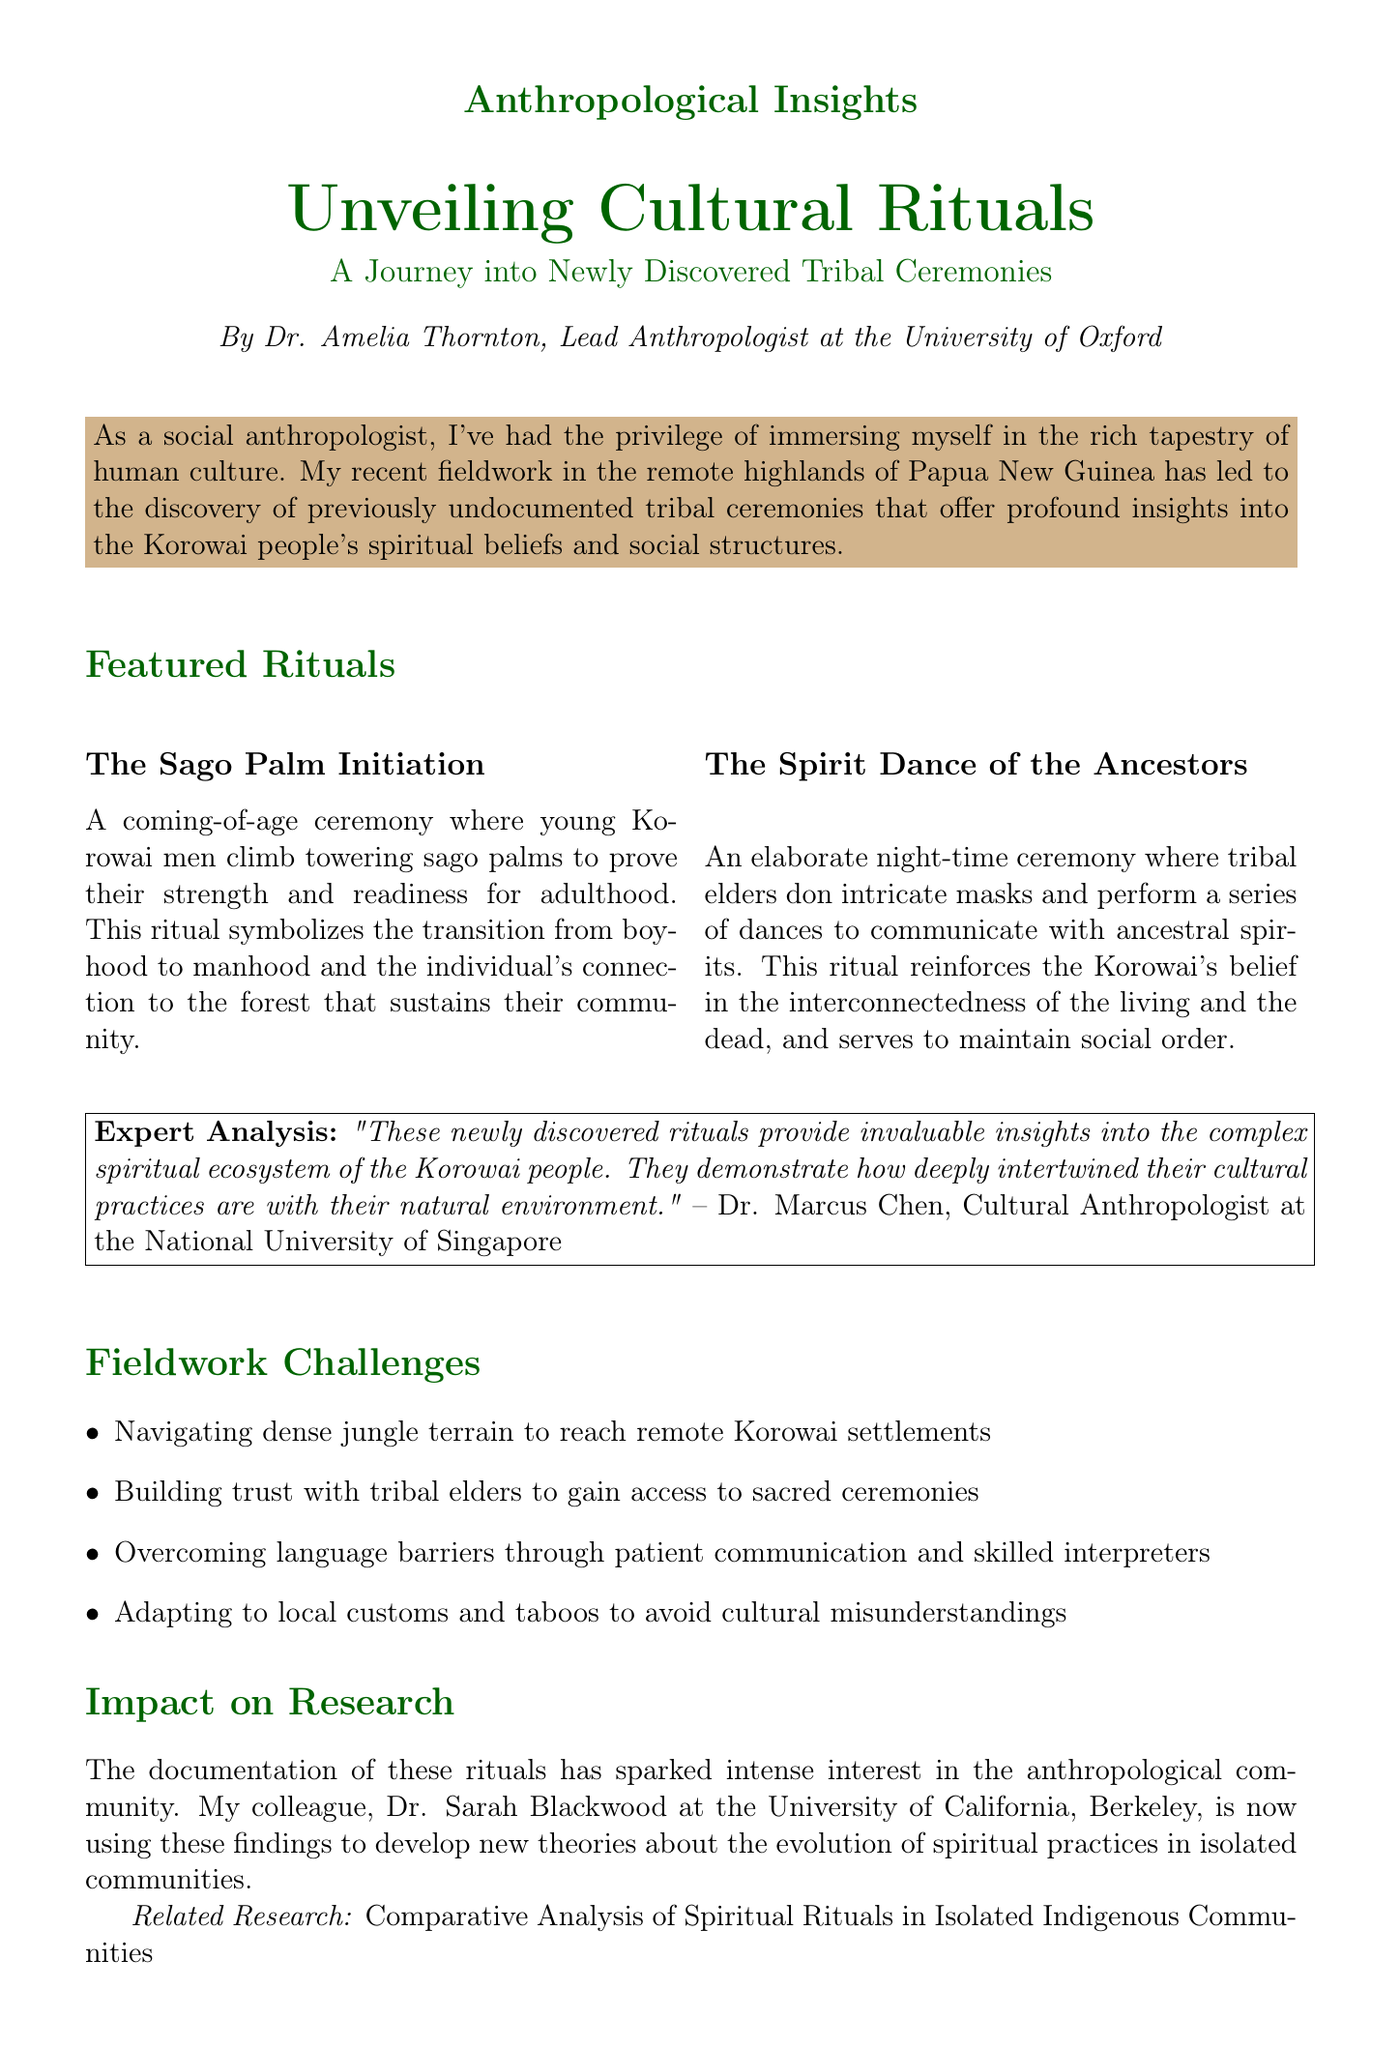What is the title of the newsletter? The title is explicitly stated at the beginning of the document.
Answer: Unveiling Cultural Rituals: A Journey into Newly Discovered Tribal Ceremonies Who is the author of the newsletter? The author's name and title are mentioned immediately below the title.
Answer: Dr. Amelia Thornton What is the significance of The Sago Palm Initiation? The significance is provided as part of the description of the ritual.
Answer: This ritual symbolizes the transition from boyhood to manhood and the individual's connection to the forest that sustains their community Which organization is involved in conservation efforts? The organization is specifically named in the conservation section of the document.
Answer: Rainforest Alliance What is the fieldwork challenge related to communication? The document lists challenges faced during fieldwork, including communication issues.
Answer: Overcoming language barriers through patient communication and skilled interpreters How many featured rituals are mentioned in the newsletter? The document includes a list of featured rituals under a specific section.
Answer: Two What is the impact of the documentation of these rituals on research? The document explains the broader implications of the findings for anthropology.
Answer: Sparked intense interest in the anthropological community Who provided the expert analysis in the newsletter? The name of the person giving the expert analysis is mentioned in a quote.
Answer: Dr. Marcus Chen 